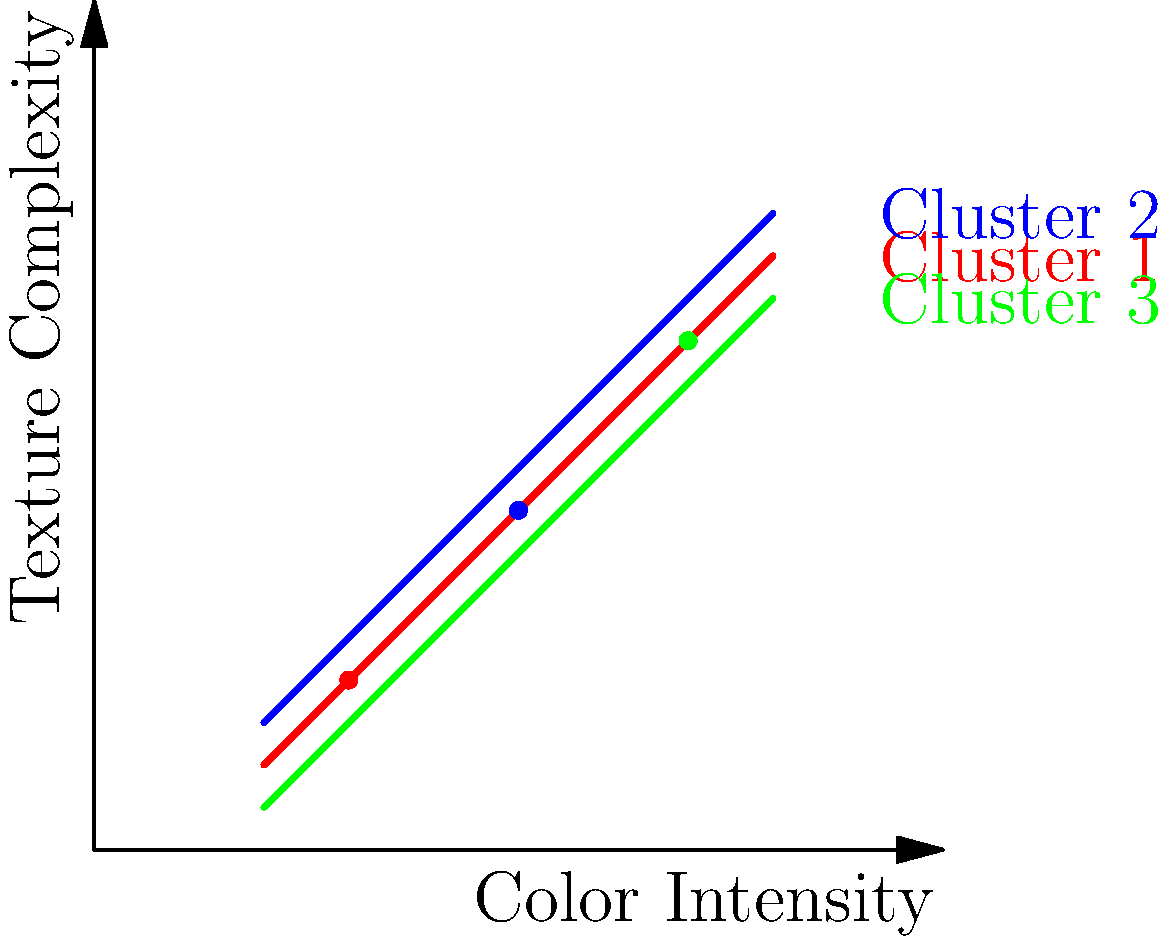As a radio DJ known for discovering underground artists, you're analyzing album cover art to identify similar styles. The graph shows three clusters of artists based on their album cover art features. Which cluster would you assign a new artist to if their album cover has a color intensity of 0.5 and a texture complexity of 0.4? To determine which cluster the new artist belongs to, we need to follow these steps:

1. Identify the coordinates of the new artist's album cover:
   - Color Intensity: 0.5
   - Texture Complexity: 0.4

2. Examine the graph and locate the point (0.5, 0.4).

3. Observe the three cluster lines:
   - Cluster 1 (red): lowest on the graph
   - Cluster 2 (blue): highest on the graph
   - Cluster 3 (green): in between Cluster 1 and Cluster 2

4. Compare the position of the point (0.5, 0.4) to the cluster lines:
   - It's above the red line (Cluster 1)
   - It's below the green line (Cluster 3)
   - It's closest to the blue line (Cluster 2)

5. Conclude that the new artist's album cover is most similar to the artists in Cluster 2 (blue).

This clustering approach allows you, as a DJ, to quickly identify artists with similar visual styles, potentially indicating similar musical genres or subcultures within the underground music scene.
Answer: Cluster 2 (blue) 